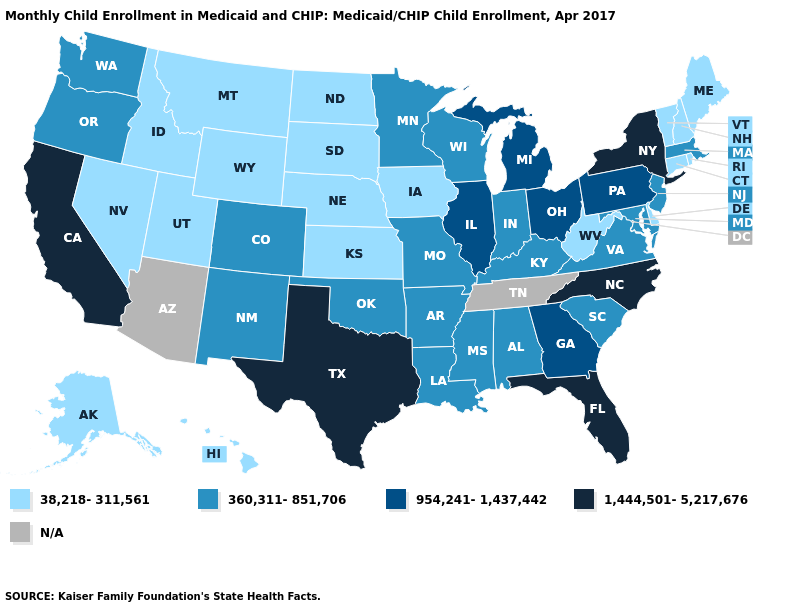Is the legend a continuous bar?
Quick response, please. No. What is the value of California?
Write a very short answer. 1,444,501-5,217,676. What is the value of Maryland?
Keep it brief. 360,311-851,706. What is the value of Texas?
Be succinct. 1,444,501-5,217,676. Name the states that have a value in the range N/A?
Answer briefly. Arizona, Tennessee. Among the states that border New Mexico , does Oklahoma have the lowest value?
Write a very short answer. No. Name the states that have a value in the range 360,311-851,706?
Keep it brief. Alabama, Arkansas, Colorado, Indiana, Kentucky, Louisiana, Maryland, Massachusetts, Minnesota, Mississippi, Missouri, New Jersey, New Mexico, Oklahoma, Oregon, South Carolina, Virginia, Washington, Wisconsin. What is the value of California?
Quick response, please. 1,444,501-5,217,676. Does the first symbol in the legend represent the smallest category?
Write a very short answer. Yes. What is the highest value in states that border Maine?
Answer briefly. 38,218-311,561. Does Rhode Island have the lowest value in the Northeast?
Short answer required. Yes. Among the states that border Alabama , does Florida have the highest value?
Answer briefly. Yes. What is the lowest value in the South?
Answer briefly. 38,218-311,561. 